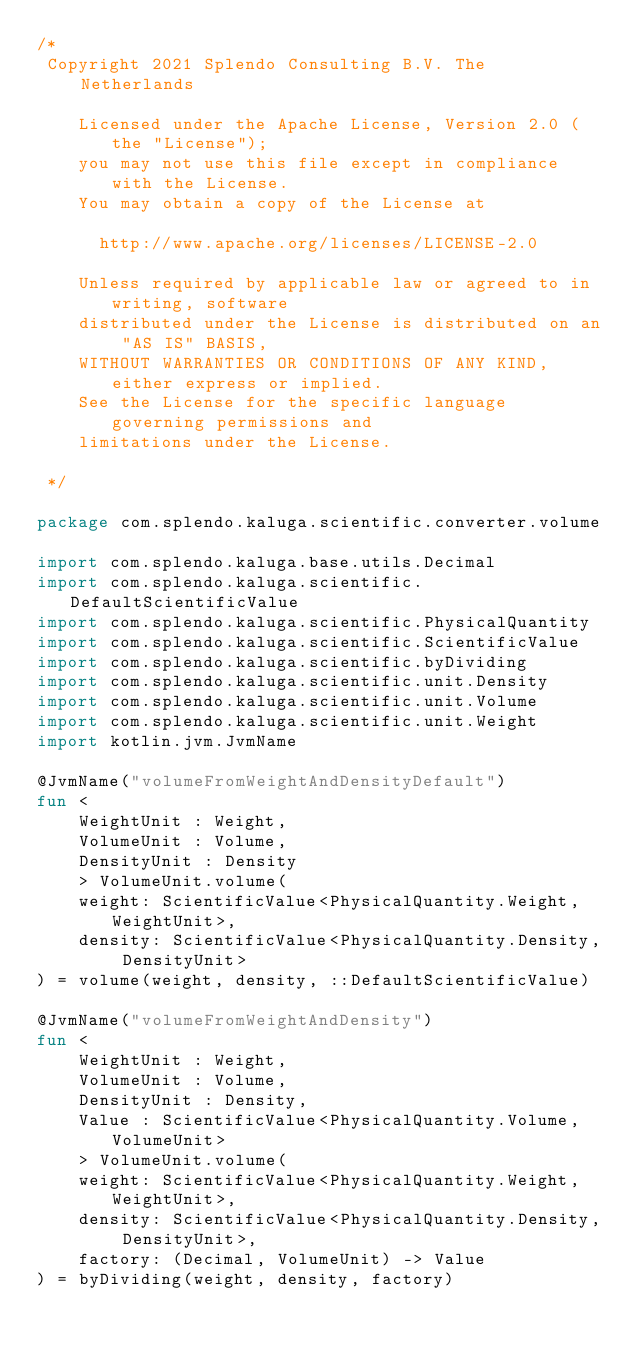<code> <loc_0><loc_0><loc_500><loc_500><_Kotlin_>/*
 Copyright 2021 Splendo Consulting B.V. The Netherlands

    Licensed under the Apache License, Version 2.0 (the "License");
    you may not use this file except in compliance with the License.
    You may obtain a copy of the License at

      http://www.apache.org/licenses/LICENSE-2.0

    Unless required by applicable law or agreed to in writing, software
    distributed under the License is distributed on an "AS IS" BASIS,
    WITHOUT WARRANTIES OR CONDITIONS OF ANY KIND, either express or implied.
    See the License for the specific language governing permissions and
    limitations under the License.

 */

package com.splendo.kaluga.scientific.converter.volume

import com.splendo.kaluga.base.utils.Decimal
import com.splendo.kaluga.scientific.DefaultScientificValue
import com.splendo.kaluga.scientific.PhysicalQuantity
import com.splendo.kaluga.scientific.ScientificValue
import com.splendo.kaluga.scientific.byDividing
import com.splendo.kaluga.scientific.unit.Density
import com.splendo.kaluga.scientific.unit.Volume
import com.splendo.kaluga.scientific.unit.Weight
import kotlin.jvm.JvmName

@JvmName("volumeFromWeightAndDensityDefault")
fun <
    WeightUnit : Weight,
    VolumeUnit : Volume,
    DensityUnit : Density
    > VolumeUnit.volume(
    weight: ScientificValue<PhysicalQuantity.Weight, WeightUnit>,
    density: ScientificValue<PhysicalQuantity.Density, DensityUnit>
) = volume(weight, density, ::DefaultScientificValue)

@JvmName("volumeFromWeightAndDensity")
fun <
    WeightUnit : Weight,
    VolumeUnit : Volume,
    DensityUnit : Density,
    Value : ScientificValue<PhysicalQuantity.Volume, VolumeUnit>
    > VolumeUnit.volume(
    weight: ScientificValue<PhysicalQuantity.Weight, WeightUnit>,
    density: ScientificValue<PhysicalQuantity.Density, DensityUnit>,
    factory: (Decimal, VolumeUnit) -> Value
) = byDividing(weight, density, factory)
</code> 